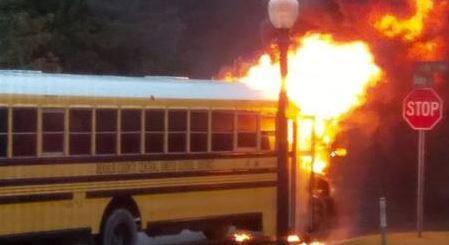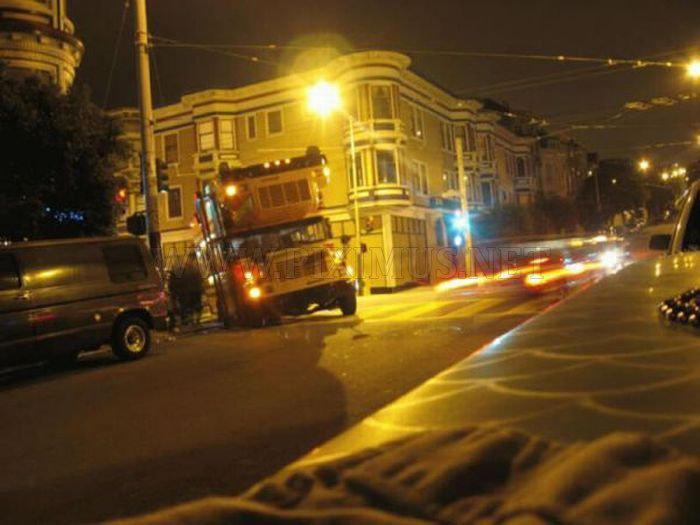The first image is the image on the left, the second image is the image on the right. Assess this claim about the two images: "One image shows a school bus on fire, and the other does not.". Correct or not? Answer yes or no. Yes. The first image is the image on the left, the second image is the image on the right. Assess this claim about the two images: "At least one school bus is on fire in only one of the images.". Correct or not? Answer yes or no. Yes. 